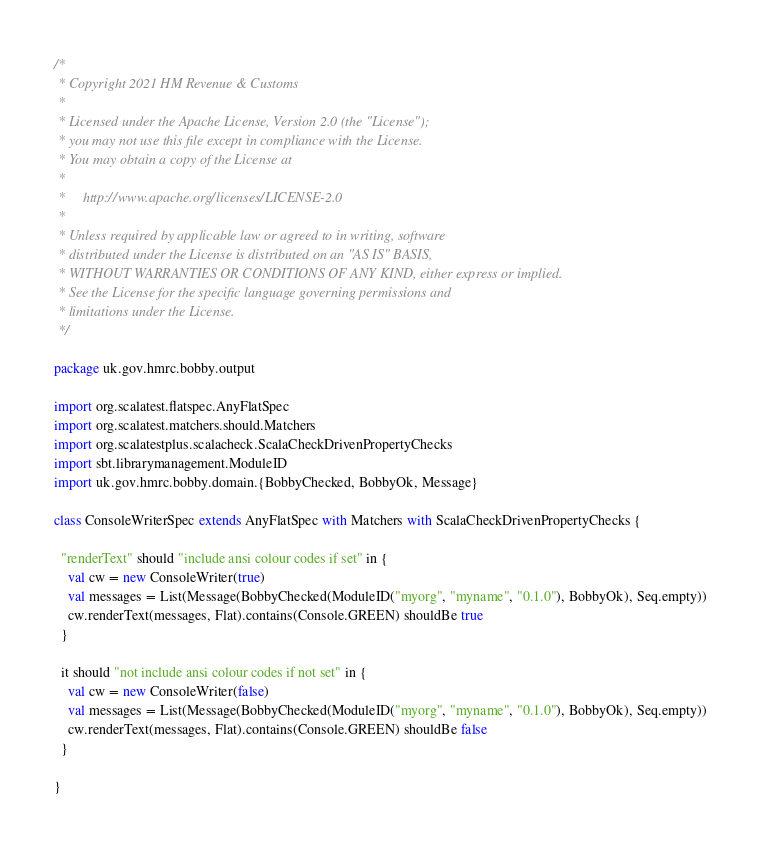Convert code to text. <code><loc_0><loc_0><loc_500><loc_500><_Scala_>/*
 * Copyright 2021 HM Revenue & Customs
 *
 * Licensed under the Apache License, Version 2.0 (the "License");
 * you may not use this file except in compliance with the License.
 * You may obtain a copy of the License at
 *
 *     http://www.apache.org/licenses/LICENSE-2.0
 *
 * Unless required by applicable law or agreed to in writing, software
 * distributed under the License is distributed on an "AS IS" BASIS,
 * WITHOUT WARRANTIES OR CONDITIONS OF ANY KIND, either express or implied.
 * See the License for the specific language governing permissions and
 * limitations under the License.
 */

package uk.gov.hmrc.bobby.output

import org.scalatest.flatspec.AnyFlatSpec
import org.scalatest.matchers.should.Matchers
import org.scalatestplus.scalacheck.ScalaCheckDrivenPropertyChecks
import sbt.librarymanagement.ModuleID
import uk.gov.hmrc.bobby.domain.{BobbyChecked, BobbyOk, Message}

class ConsoleWriterSpec extends AnyFlatSpec with Matchers with ScalaCheckDrivenPropertyChecks {

  "renderText" should "include ansi colour codes if set" in {
    val cw = new ConsoleWriter(true)
    val messages = List(Message(BobbyChecked(ModuleID("myorg", "myname", "0.1.0"), BobbyOk), Seq.empty))
    cw.renderText(messages, Flat).contains(Console.GREEN) shouldBe true
  }

  it should "not include ansi colour codes if not set" in {
    val cw = new ConsoleWriter(false)
    val messages = List(Message(BobbyChecked(ModuleID("myorg", "myname", "0.1.0"), BobbyOk), Seq.empty))
    cw.renderText(messages, Flat).contains(Console.GREEN) shouldBe false
  }

}
</code> 